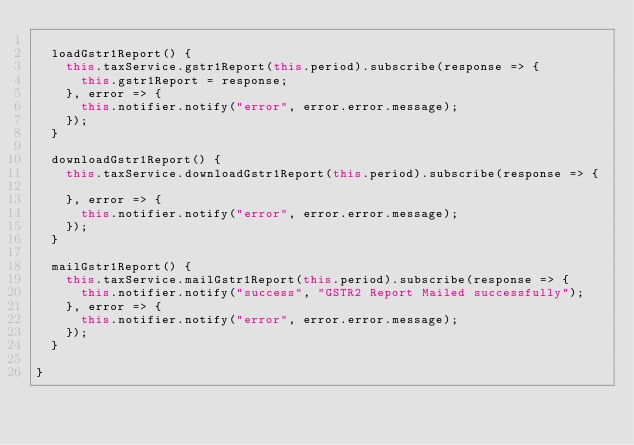Convert code to text. <code><loc_0><loc_0><loc_500><loc_500><_TypeScript_>
  loadGstr1Report() {
    this.taxService.gstr1Report(this.period).subscribe(response => {
      this.gstr1Report = response;
    }, error => {
      this.notifier.notify("error", error.error.message);
    });
  }

  downloadGstr1Report() {
    this.taxService.downloadGstr1Report(this.period).subscribe(response => {

    }, error => {
      this.notifier.notify("error", error.error.message);
    });
  }

  mailGstr1Report() {
    this.taxService.mailGstr1Report(this.period).subscribe(response => {
      this.notifier.notify("success", "GSTR2 Report Mailed successfully");
    }, error => {
      this.notifier.notify("error", error.error.message);
    });
  }

}
</code> 